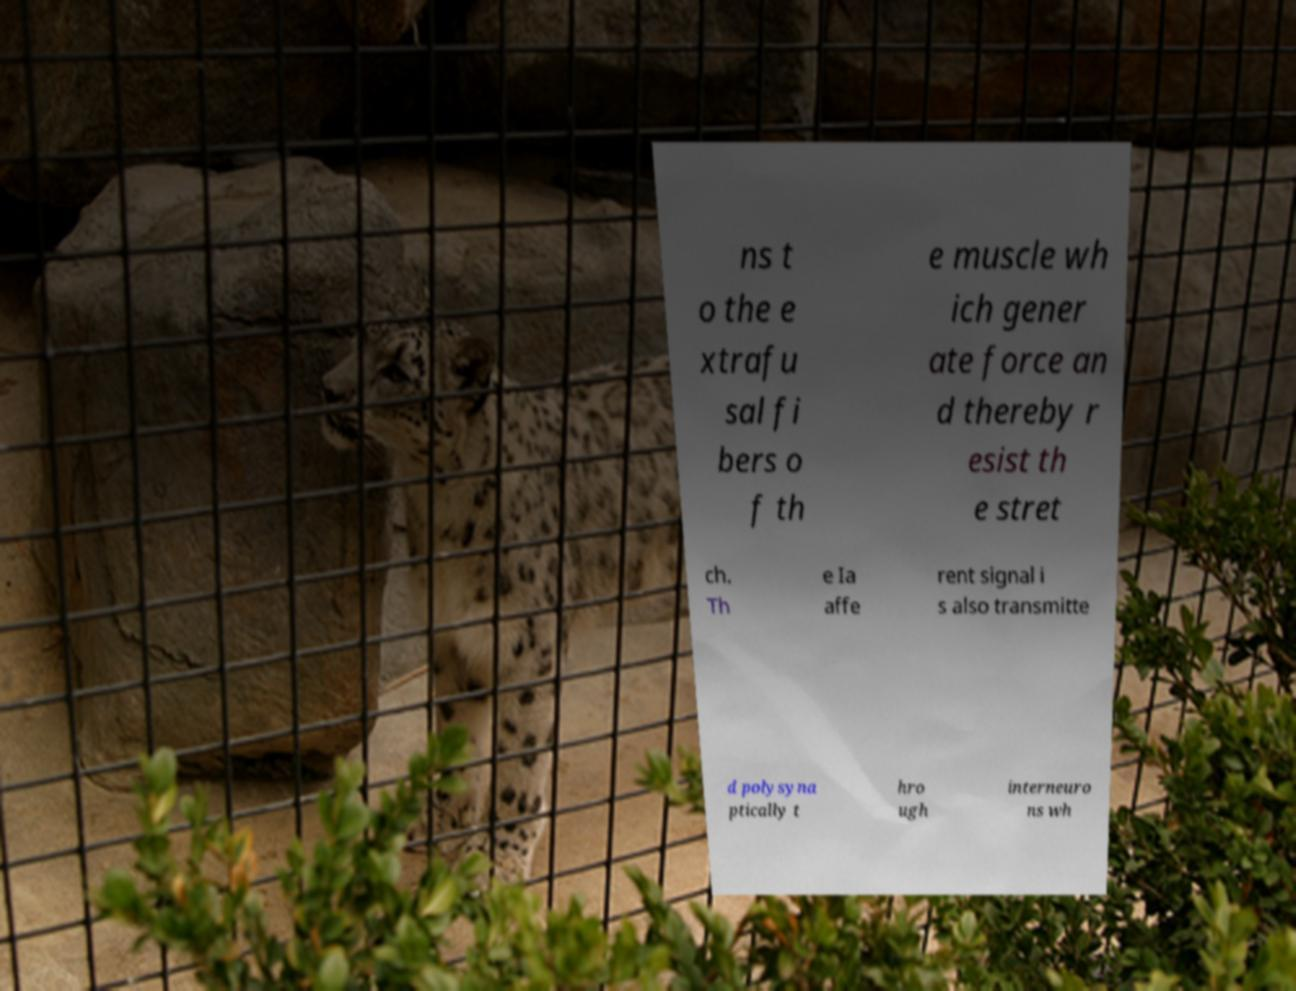Could you assist in decoding the text presented in this image and type it out clearly? ns t o the e xtrafu sal fi bers o f th e muscle wh ich gener ate force an d thereby r esist th e stret ch. Th e Ia affe rent signal i s also transmitte d polysyna ptically t hro ugh interneuro ns wh 